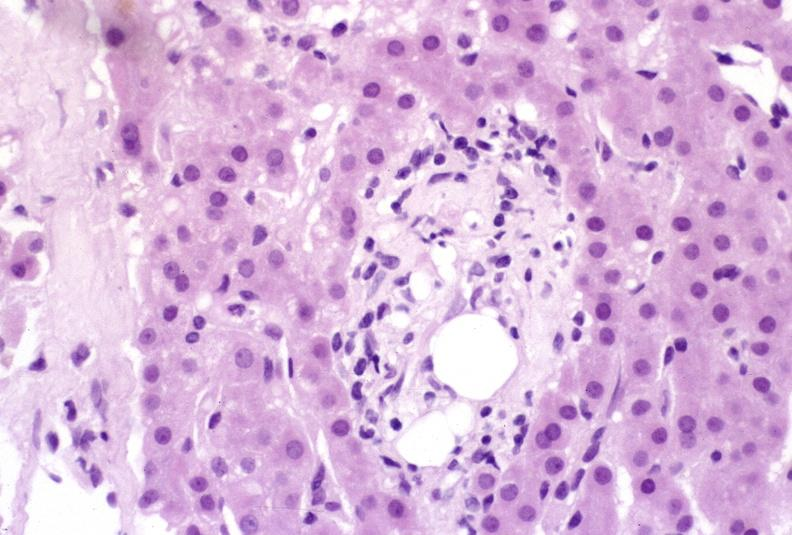what is present?
Answer the question using a single word or phrase. Liver 